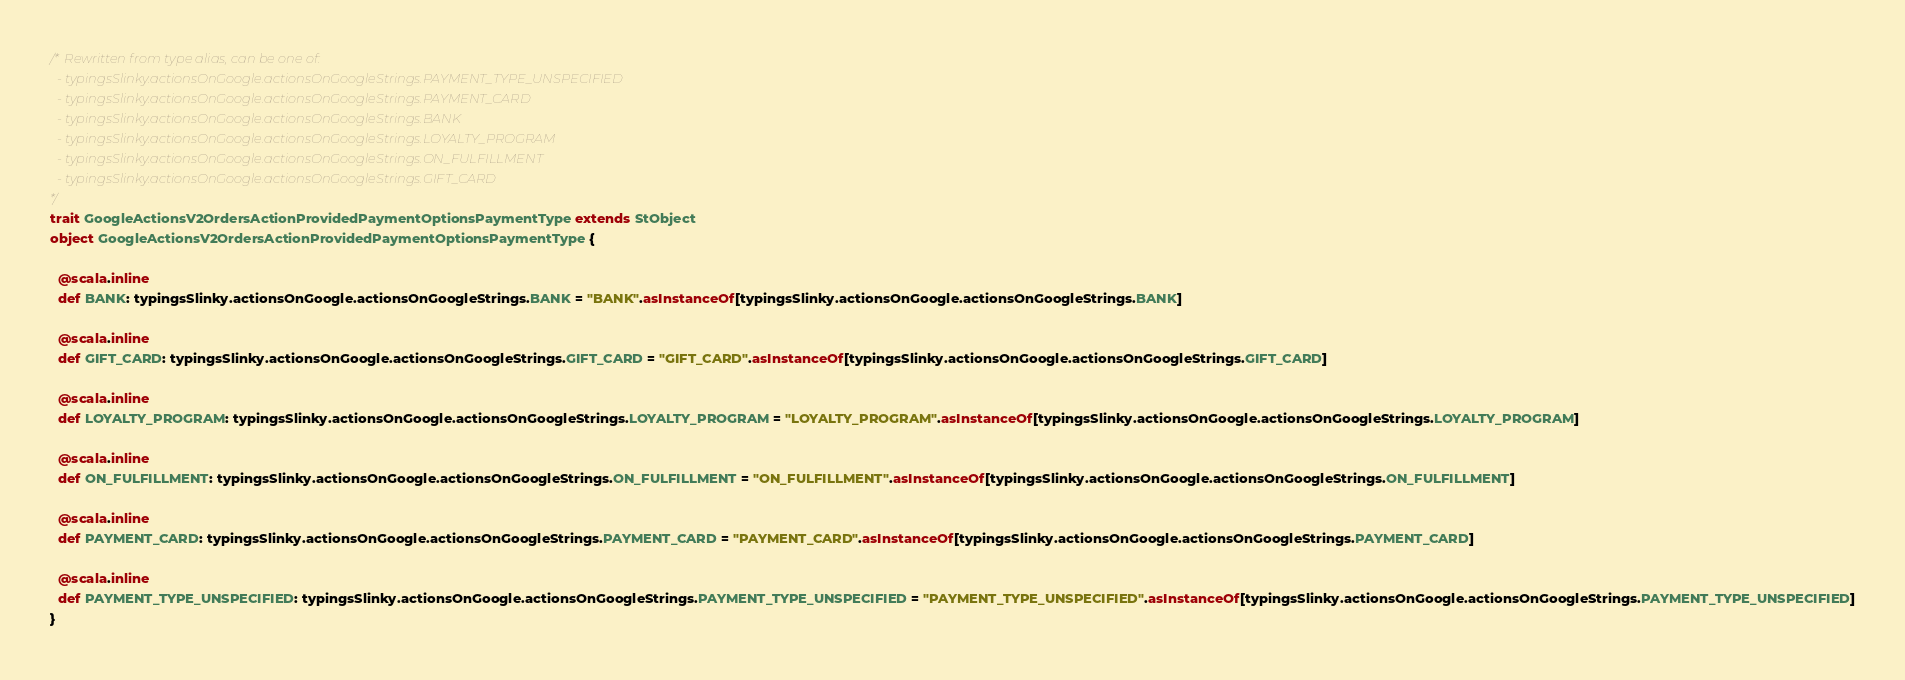Convert code to text. <code><loc_0><loc_0><loc_500><loc_500><_Scala_>/* Rewritten from type alias, can be one of: 
  - typingsSlinky.actionsOnGoogle.actionsOnGoogleStrings.PAYMENT_TYPE_UNSPECIFIED
  - typingsSlinky.actionsOnGoogle.actionsOnGoogleStrings.PAYMENT_CARD
  - typingsSlinky.actionsOnGoogle.actionsOnGoogleStrings.BANK
  - typingsSlinky.actionsOnGoogle.actionsOnGoogleStrings.LOYALTY_PROGRAM
  - typingsSlinky.actionsOnGoogle.actionsOnGoogleStrings.ON_FULFILLMENT
  - typingsSlinky.actionsOnGoogle.actionsOnGoogleStrings.GIFT_CARD
*/
trait GoogleActionsV2OrdersActionProvidedPaymentOptionsPaymentType extends StObject
object GoogleActionsV2OrdersActionProvidedPaymentOptionsPaymentType {
  
  @scala.inline
  def BANK: typingsSlinky.actionsOnGoogle.actionsOnGoogleStrings.BANK = "BANK".asInstanceOf[typingsSlinky.actionsOnGoogle.actionsOnGoogleStrings.BANK]
  
  @scala.inline
  def GIFT_CARD: typingsSlinky.actionsOnGoogle.actionsOnGoogleStrings.GIFT_CARD = "GIFT_CARD".asInstanceOf[typingsSlinky.actionsOnGoogle.actionsOnGoogleStrings.GIFT_CARD]
  
  @scala.inline
  def LOYALTY_PROGRAM: typingsSlinky.actionsOnGoogle.actionsOnGoogleStrings.LOYALTY_PROGRAM = "LOYALTY_PROGRAM".asInstanceOf[typingsSlinky.actionsOnGoogle.actionsOnGoogleStrings.LOYALTY_PROGRAM]
  
  @scala.inline
  def ON_FULFILLMENT: typingsSlinky.actionsOnGoogle.actionsOnGoogleStrings.ON_FULFILLMENT = "ON_FULFILLMENT".asInstanceOf[typingsSlinky.actionsOnGoogle.actionsOnGoogleStrings.ON_FULFILLMENT]
  
  @scala.inline
  def PAYMENT_CARD: typingsSlinky.actionsOnGoogle.actionsOnGoogleStrings.PAYMENT_CARD = "PAYMENT_CARD".asInstanceOf[typingsSlinky.actionsOnGoogle.actionsOnGoogleStrings.PAYMENT_CARD]
  
  @scala.inline
  def PAYMENT_TYPE_UNSPECIFIED: typingsSlinky.actionsOnGoogle.actionsOnGoogleStrings.PAYMENT_TYPE_UNSPECIFIED = "PAYMENT_TYPE_UNSPECIFIED".asInstanceOf[typingsSlinky.actionsOnGoogle.actionsOnGoogleStrings.PAYMENT_TYPE_UNSPECIFIED]
}
</code> 